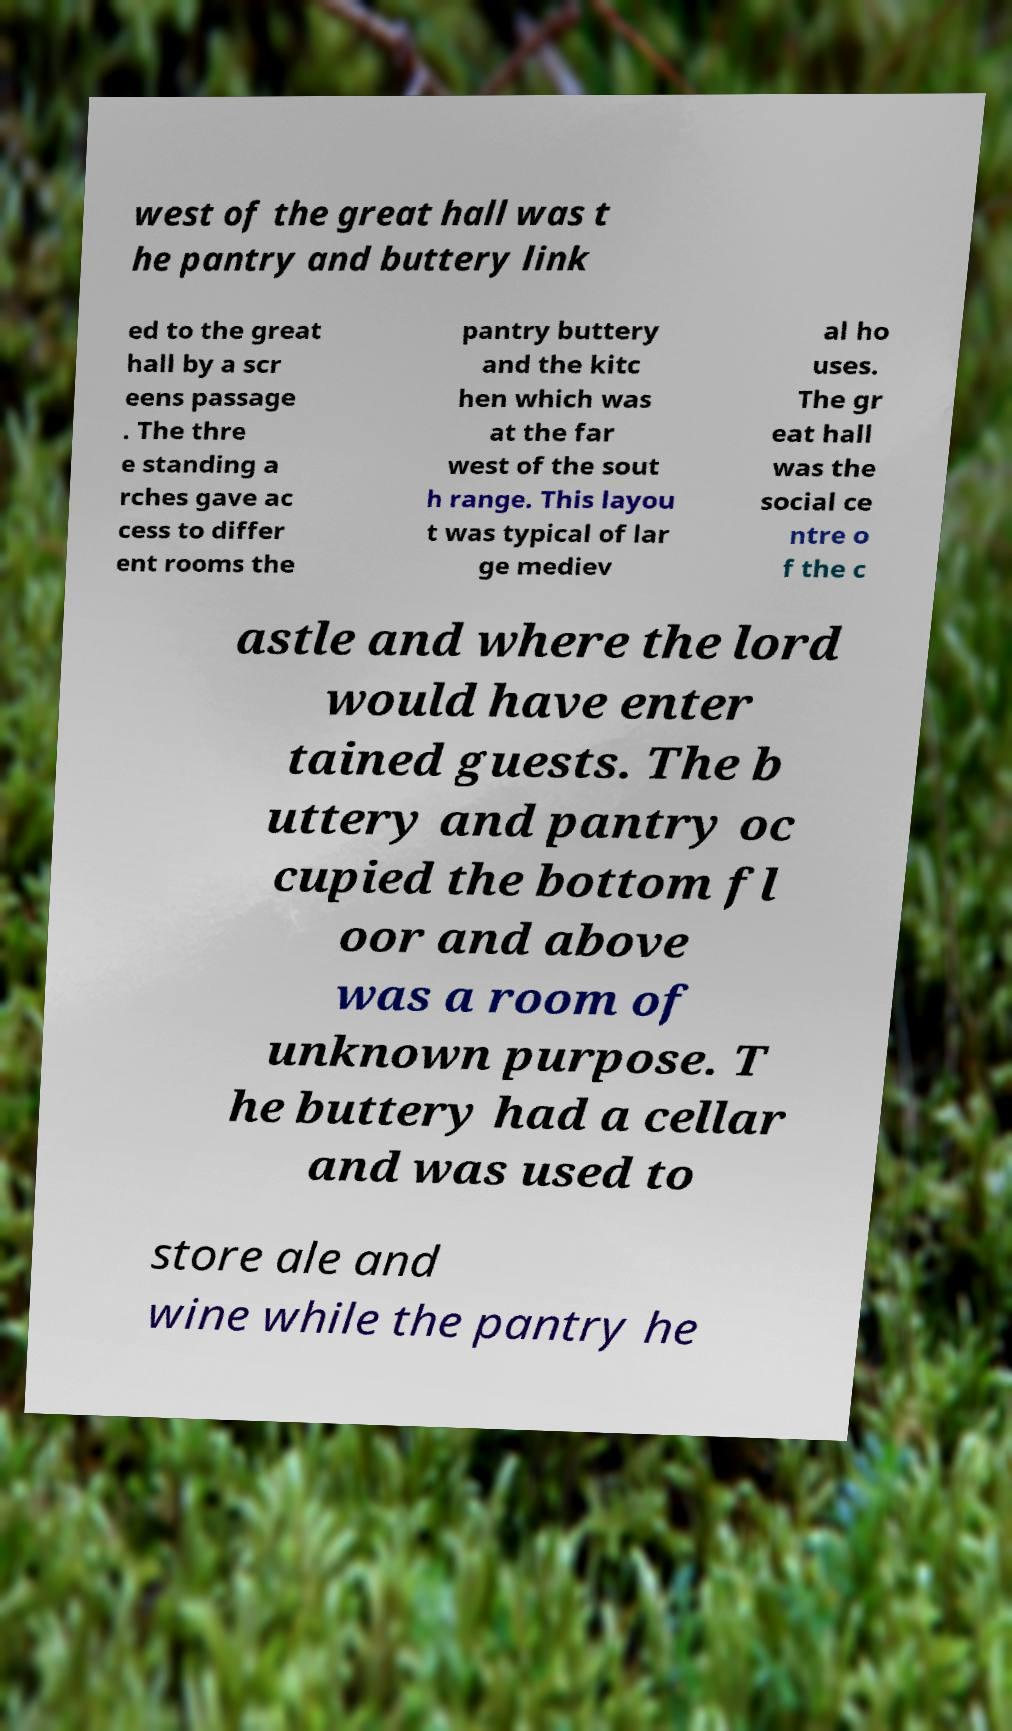Could you extract and type out the text from this image? west of the great hall was t he pantry and buttery link ed to the great hall by a scr eens passage . The thre e standing a rches gave ac cess to differ ent rooms the pantry buttery and the kitc hen which was at the far west of the sout h range. This layou t was typical of lar ge mediev al ho uses. The gr eat hall was the social ce ntre o f the c astle and where the lord would have enter tained guests. The b uttery and pantry oc cupied the bottom fl oor and above was a room of unknown purpose. T he buttery had a cellar and was used to store ale and wine while the pantry he 